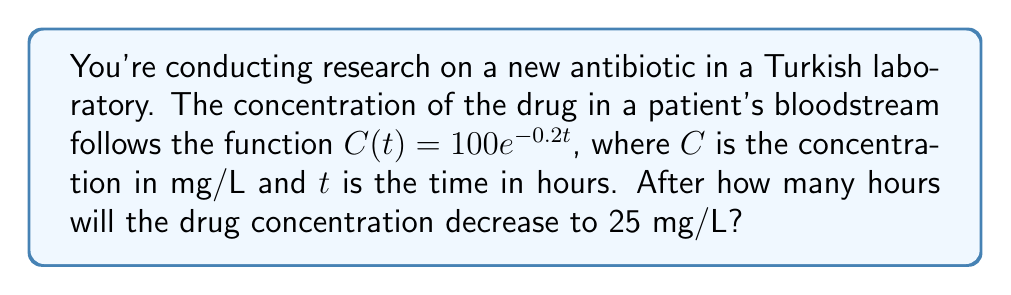Teach me how to tackle this problem. Let's approach this step-by-step:

1) We're given the function $C(t) = 100e^{-0.2t}$

2) We need to find $t$ when $C(t) = 25$

3) Let's set up the equation:
   $25 = 100e^{-0.2t}$

4) Divide both sides by 100:
   $\frac{25}{100} = e^{-0.2t}$
   $0.25 = e^{-0.2t}$

5) Take the natural logarithm of both sides:
   $\ln(0.25) = \ln(e^{-0.2t})$

6) Simplify the right side using the property of logarithms:
   $\ln(0.25) = -0.2t$

7) Solve for $t$:
   $t = -\frac{\ln(0.25)}{0.2}$

8) Calculate:
   $t = -\frac{\ln(0.25)}{0.2} \approx 6.93$ hours

Therefore, it will take approximately 6.93 hours for the drug concentration to decrease to 25 mg/L.
Answer: $6.93$ hours 